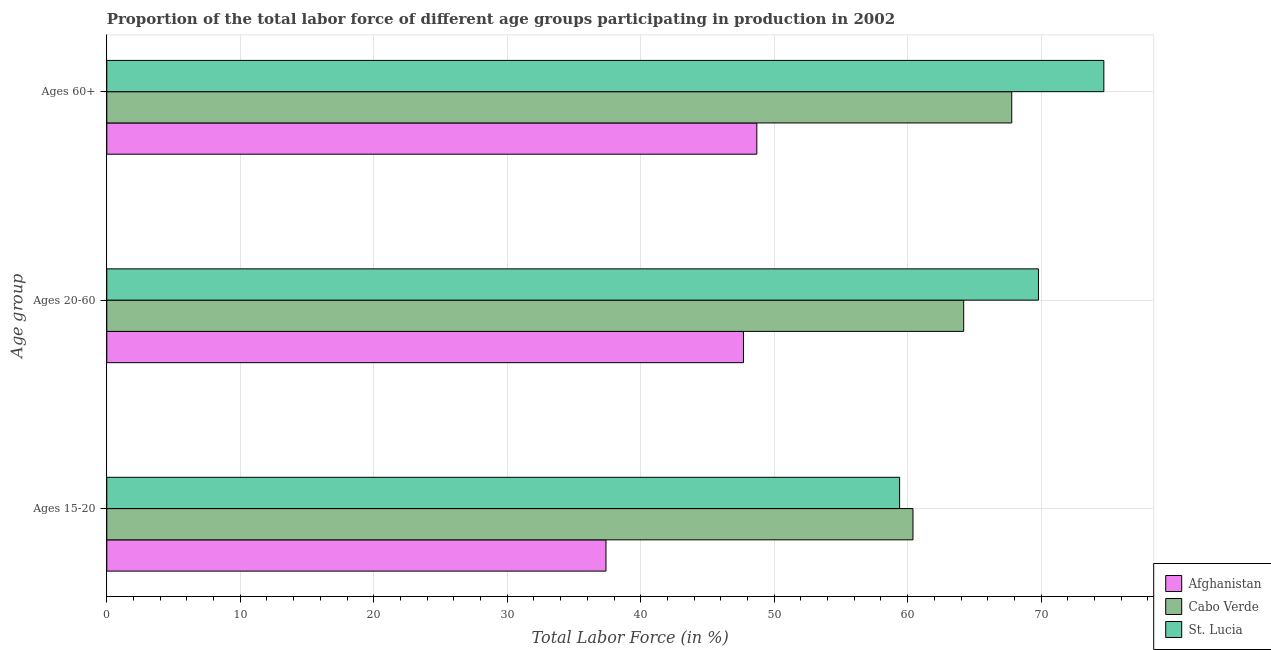How many different coloured bars are there?
Keep it short and to the point. 3. Are the number of bars per tick equal to the number of legend labels?
Give a very brief answer. Yes. How many bars are there on the 3rd tick from the top?
Keep it short and to the point. 3. What is the label of the 3rd group of bars from the top?
Your response must be concise. Ages 15-20. What is the percentage of labor force above age 60 in Cabo Verde?
Provide a succinct answer. 67.8. Across all countries, what is the maximum percentage of labor force above age 60?
Your answer should be very brief. 74.7. Across all countries, what is the minimum percentage of labor force within the age group 20-60?
Your answer should be very brief. 47.7. In which country was the percentage of labor force within the age group 20-60 maximum?
Your response must be concise. St. Lucia. In which country was the percentage of labor force above age 60 minimum?
Your response must be concise. Afghanistan. What is the total percentage of labor force above age 60 in the graph?
Your answer should be compact. 191.2. What is the difference between the percentage of labor force above age 60 in Afghanistan and that in Cabo Verde?
Your answer should be compact. -19.1. What is the difference between the percentage of labor force within the age group 20-60 in St. Lucia and the percentage of labor force within the age group 15-20 in Cabo Verde?
Provide a succinct answer. 9.4. What is the average percentage of labor force above age 60 per country?
Provide a succinct answer. 63.73. What is the difference between the percentage of labor force within the age group 20-60 and percentage of labor force within the age group 15-20 in Cabo Verde?
Your answer should be compact. 3.8. What is the ratio of the percentage of labor force above age 60 in Afghanistan to that in Cabo Verde?
Your answer should be very brief. 0.72. What is the difference between the highest and the second highest percentage of labor force within the age group 20-60?
Offer a very short reply. 5.6. What is the difference between the highest and the lowest percentage of labor force above age 60?
Your response must be concise. 26. Is the sum of the percentage of labor force within the age group 15-20 in St. Lucia and Afghanistan greater than the maximum percentage of labor force within the age group 20-60 across all countries?
Provide a short and direct response. Yes. What does the 3rd bar from the top in Ages 15-20 represents?
Keep it short and to the point. Afghanistan. What does the 2nd bar from the bottom in Ages 20-60 represents?
Give a very brief answer. Cabo Verde. Are all the bars in the graph horizontal?
Keep it short and to the point. Yes. How many countries are there in the graph?
Your answer should be compact. 3. Are the values on the major ticks of X-axis written in scientific E-notation?
Your answer should be very brief. No. Does the graph contain any zero values?
Make the answer very short. No. What is the title of the graph?
Your response must be concise. Proportion of the total labor force of different age groups participating in production in 2002. What is the label or title of the Y-axis?
Your answer should be very brief. Age group. What is the Total Labor Force (in %) of Afghanistan in Ages 15-20?
Offer a terse response. 37.4. What is the Total Labor Force (in %) in Cabo Verde in Ages 15-20?
Your response must be concise. 60.4. What is the Total Labor Force (in %) in St. Lucia in Ages 15-20?
Keep it short and to the point. 59.4. What is the Total Labor Force (in %) of Afghanistan in Ages 20-60?
Offer a terse response. 47.7. What is the Total Labor Force (in %) in Cabo Verde in Ages 20-60?
Your answer should be compact. 64.2. What is the Total Labor Force (in %) of St. Lucia in Ages 20-60?
Ensure brevity in your answer.  69.8. What is the Total Labor Force (in %) in Afghanistan in Ages 60+?
Your answer should be very brief. 48.7. What is the Total Labor Force (in %) of Cabo Verde in Ages 60+?
Give a very brief answer. 67.8. What is the Total Labor Force (in %) of St. Lucia in Ages 60+?
Your response must be concise. 74.7. Across all Age group, what is the maximum Total Labor Force (in %) of Afghanistan?
Your answer should be compact. 48.7. Across all Age group, what is the maximum Total Labor Force (in %) of Cabo Verde?
Your answer should be compact. 67.8. Across all Age group, what is the maximum Total Labor Force (in %) in St. Lucia?
Provide a succinct answer. 74.7. Across all Age group, what is the minimum Total Labor Force (in %) of Afghanistan?
Provide a short and direct response. 37.4. Across all Age group, what is the minimum Total Labor Force (in %) in Cabo Verde?
Your answer should be very brief. 60.4. Across all Age group, what is the minimum Total Labor Force (in %) in St. Lucia?
Offer a terse response. 59.4. What is the total Total Labor Force (in %) of Afghanistan in the graph?
Your answer should be compact. 133.8. What is the total Total Labor Force (in %) in Cabo Verde in the graph?
Make the answer very short. 192.4. What is the total Total Labor Force (in %) in St. Lucia in the graph?
Give a very brief answer. 203.9. What is the difference between the Total Labor Force (in %) in St. Lucia in Ages 15-20 and that in Ages 20-60?
Keep it short and to the point. -10.4. What is the difference between the Total Labor Force (in %) in Afghanistan in Ages 15-20 and that in Ages 60+?
Make the answer very short. -11.3. What is the difference between the Total Labor Force (in %) in Cabo Verde in Ages 15-20 and that in Ages 60+?
Keep it short and to the point. -7.4. What is the difference between the Total Labor Force (in %) of St. Lucia in Ages 15-20 and that in Ages 60+?
Your answer should be compact. -15.3. What is the difference between the Total Labor Force (in %) of St. Lucia in Ages 20-60 and that in Ages 60+?
Your answer should be compact. -4.9. What is the difference between the Total Labor Force (in %) of Afghanistan in Ages 15-20 and the Total Labor Force (in %) of Cabo Verde in Ages 20-60?
Provide a short and direct response. -26.8. What is the difference between the Total Labor Force (in %) in Afghanistan in Ages 15-20 and the Total Labor Force (in %) in St. Lucia in Ages 20-60?
Your answer should be compact. -32.4. What is the difference between the Total Labor Force (in %) in Afghanistan in Ages 15-20 and the Total Labor Force (in %) in Cabo Verde in Ages 60+?
Make the answer very short. -30.4. What is the difference between the Total Labor Force (in %) in Afghanistan in Ages 15-20 and the Total Labor Force (in %) in St. Lucia in Ages 60+?
Provide a succinct answer. -37.3. What is the difference between the Total Labor Force (in %) in Cabo Verde in Ages 15-20 and the Total Labor Force (in %) in St. Lucia in Ages 60+?
Provide a succinct answer. -14.3. What is the difference between the Total Labor Force (in %) in Afghanistan in Ages 20-60 and the Total Labor Force (in %) in Cabo Verde in Ages 60+?
Make the answer very short. -20.1. What is the difference between the Total Labor Force (in %) in Cabo Verde in Ages 20-60 and the Total Labor Force (in %) in St. Lucia in Ages 60+?
Keep it short and to the point. -10.5. What is the average Total Labor Force (in %) of Afghanistan per Age group?
Give a very brief answer. 44.6. What is the average Total Labor Force (in %) in Cabo Verde per Age group?
Your response must be concise. 64.13. What is the average Total Labor Force (in %) in St. Lucia per Age group?
Your answer should be compact. 67.97. What is the difference between the Total Labor Force (in %) of Afghanistan and Total Labor Force (in %) of Cabo Verde in Ages 15-20?
Keep it short and to the point. -23. What is the difference between the Total Labor Force (in %) of Afghanistan and Total Labor Force (in %) of Cabo Verde in Ages 20-60?
Give a very brief answer. -16.5. What is the difference between the Total Labor Force (in %) of Afghanistan and Total Labor Force (in %) of St. Lucia in Ages 20-60?
Provide a succinct answer. -22.1. What is the difference between the Total Labor Force (in %) of Cabo Verde and Total Labor Force (in %) of St. Lucia in Ages 20-60?
Your answer should be very brief. -5.6. What is the difference between the Total Labor Force (in %) of Afghanistan and Total Labor Force (in %) of Cabo Verde in Ages 60+?
Offer a very short reply. -19.1. What is the difference between the Total Labor Force (in %) of Cabo Verde and Total Labor Force (in %) of St. Lucia in Ages 60+?
Your response must be concise. -6.9. What is the ratio of the Total Labor Force (in %) in Afghanistan in Ages 15-20 to that in Ages 20-60?
Ensure brevity in your answer.  0.78. What is the ratio of the Total Labor Force (in %) of Cabo Verde in Ages 15-20 to that in Ages 20-60?
Offer a very short reply. 0.94. What is the ratio of the Total Labor Force (in %) in St. Lucia in Ages 15-20 to that in Ages 20-60?
Offer a very short reply. 0.85. What is the ratio of the Total Labor Force (in %) of Afghanistan in Ages 15-20 to that in Ages 60+?
Keep it short and to the point. 0.77. What is the ratio of the Total Labor Force (in %) in Cabo Verde in Ages 15-20 to that in Ages 60+?
Offer a terse response. 0.89. What is the ratio of the Total Labor Force (in %) in St. Lucia in Ages 15-20 to that in Ages 60+?
Make the answer very short. 0.8. What is the ratio of the Total Labor Force (in %) in Afghanistan in Ages 20-60 to that in Ages 60+?
Make the answer very short. 0.98. What is the ratio of the Total Labor Force (in %) in Cabo Verde in Ages 20-60 to that in Ages 60+?
Your answer should be compact. 0.95. What is the ratio of the Total Labor Force (in %) of St. Lucia in Ages 20-60 to that in Ages 60+?
Offer a terse response. 0.93. What is the difference between the highest and the second highest Total Labor Force (in %) of Afghanistan?
Your response must be concise. 1. What is the difference between the highest and the lowest Total Labor Force (in %) of Afghanistan?
Ensure brevity in your answer.  11.3. What is the difference between the highest and the lowest Total Labor Force (in %) in Cabo Verde?
Your answer should be very brief. 7.4. 